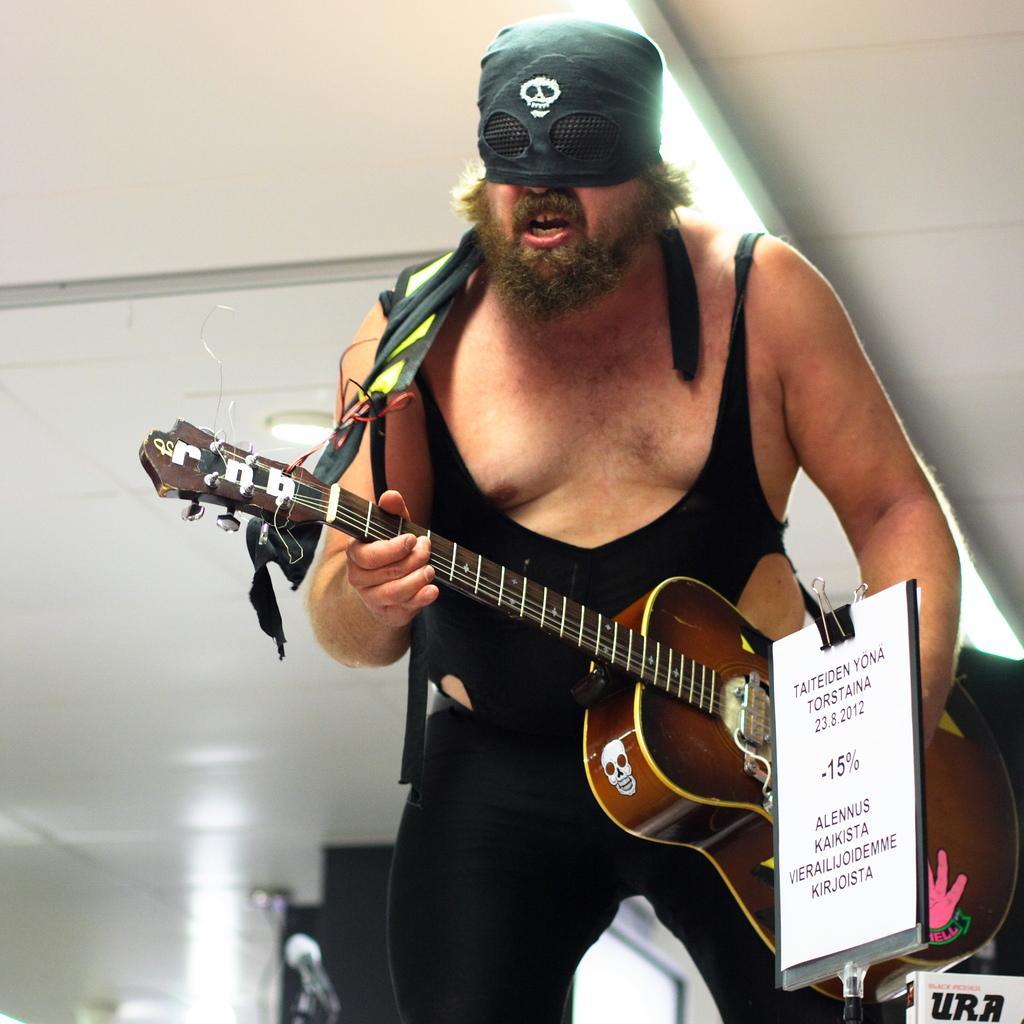Describe this image in one or two sentences. Here we can see one man standing and playing guitar. He wore mask over his face. This is a board with clip. At the top we can see ceiling with lights. This is a mike. 